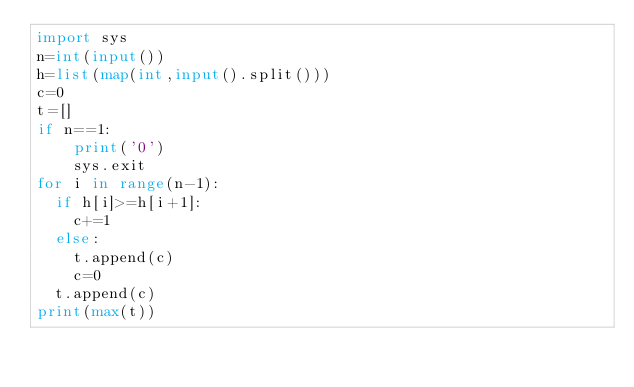<code> <loc_0><loc_0><loc_500><loc_500><_Python_>import sys
n=int(input())
h=list(map(int,input().split()))
c=0
t=[]
if n==1:
    print('0')
    sys.exit
for i in range(n-1):
  if h[i]>=h[i+1]:
    c+=1
  else:
    t.append(c)
    c=0
  t.append(c)
print(max(t))
</code> 